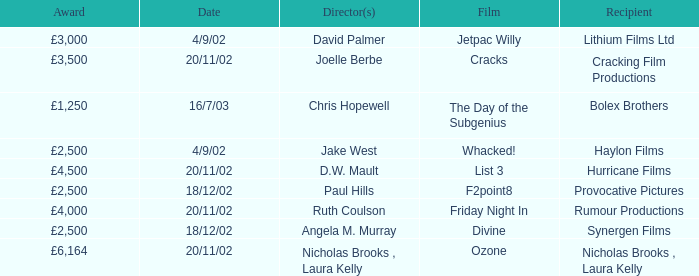Who earned a £3,000 prize on the 9th of april, 2002? Lithium Films Ltd. 